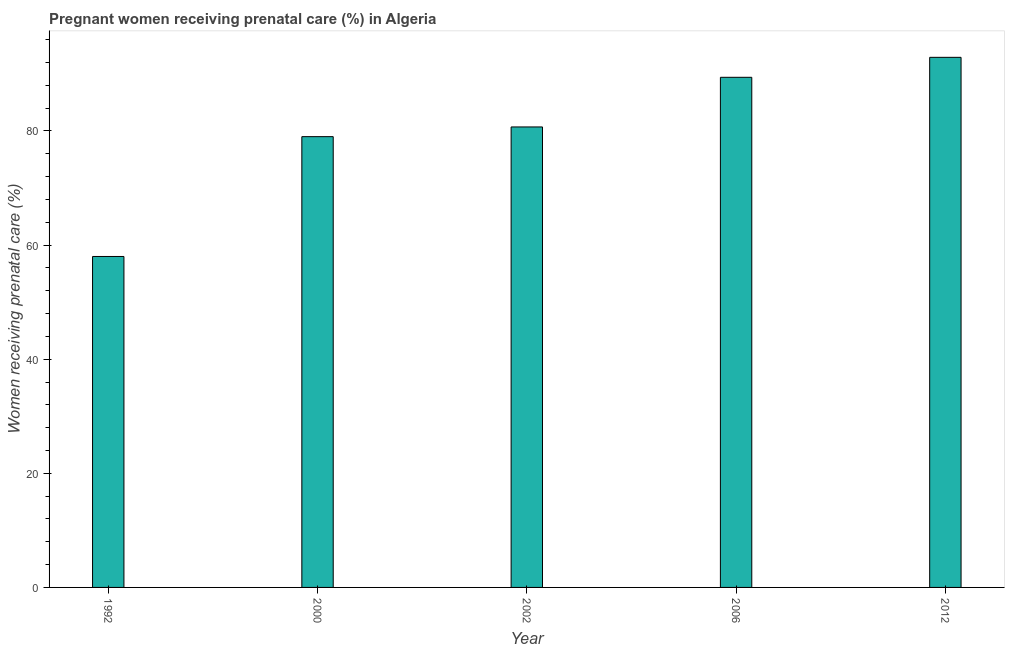Does the graph contain any zero values?
Your answer should be very brief. No. What is the title of the graph?
Give a very brief answer. Pregnant women receiving prenatal care (%) in Algeria. What is the label or title of the X-axis?
Provide a short and direct response. Year. What is the label or title of the Y-axis?
Offer a terse response. Women receiving prenatal care (%). What is the percentage of pregnant women receiving prenatal care in 2000?
Provide a short and direct response. 79. Across all years, what is the maximum percentage of pregnant women receiving prenatal care?
Offer a terse response. 92.9. In which year was the percentage of pregnant women receiving prenatal care maximum?
Provide a succinct answer. 2012. What is the difference between the percentage of pregnant women receiving prenatal care in 2000 and 2002?
Your response must be concise. -1.7. What is the median percentage of pregnant women receiving prenatal care?
Your answer should be very brief. 80.7. Do a majority of the years between 2002 and 2006 (inclusive) have percentage of pregnant women receiving prenatal care greater than 76 %?
Ensure brevity in your answer.  Yes. What is the ratio of the percentage of pregnant women receiving prenatal care in 1992 to that in 2006?
Make the answer very short. 0.65. Is the percentage of pregnant women receiving prenatal care in 2002 less than that in 2006?
Provide a succinct answer. Yes. What is the difference between the highest and the second highest percentage of pregnant women receiving prenatal care?
Offer a terse response. 3.5. What is the difference between the highest and the lowest percentage of pregnant women receiving prenatal care?
Your response must be concise. 34.9. In how many years, is the percentage of pregnant women receiving prenatal care greater than the average percentage of pregnant women receiving prenatal care taken over all years?
Provide a short and direct response. 3. Are all the bars in the graph horizontal?
Your answer should be compact. No. What is the Women receiving prenatal care (%) of 1992?
Offer a very short reply. 58. What is the Women receiving prenatal care (%) in 2000?
Provide a succinct answer. 79. What is the Women receiving prenatal care (%) of 2002?
Provide a succinct answer. 80.7. What is the Women receiving prenatal care (%) of 2006?
Make the answer very short. 89.4. What is the Women receiving prenatal care (%) of 2012?
Your answer should be very brief. 92.9. What is the difference between the Women receiving prenatal care (%) in 1992 and 2002?
Your answer should be compact. -22.7. What is the difference between the Women receiving prenatal care (%) in 1992 and 2006?
Offer a terse response. -31.4. What is the difference between the Women receiving prenatal care (%) in 1992 and 2012?
Keep it short and to the point. -34.9. What is the difference between the Women receiving prenatal care (%) in 2000 and 2002?
Provide a short and direct response. -1.7. What is the difference between the Women receiving prenatal care (%) in 2000 and 2006?
Your response must be concise. -10.4. What is the difference between the Women receiving prenatal care (%) in 2000 and 2012?
Your answer should be compact. -13.9. What is the difference between the Women receiving prenatal care (%) in 2002 and 2006?
Your response must be concise. -8.7. What is the ratio of the Women receiving prenatal care (%) in 1992 to that in 2000?
Your answer should be very brief. 0.73. What is the ratio of the Women receiving prenatal care (%) in 1992 to that in 2002?
Keep it short and to the point. 0.72. What is the ratio of the Women receiving prenatal care (%) in 1992 to that in 2006?
Your answer should be compact. 0.65. What is the ratio of the Women receiving prenatal care (%) in 1992 to that in 2012?
Make the answer very short. 0.62. What is the ratio of the Women receiving prenatal care (%) in 2000 to that in 2006?
Make the answer very short. 0.88. What is the ratio of the Women receiving prenatal care (%) in 2002 to that in 2006?
Provide a short and direct response. 0.9. What is the ratio of the Women receiving prenatal care (%) in 2002 to that in 2012?
Keep it short and to the point. 0.87. What is the ratio of the Women receiving prenatal care (%) in 2006 to that in 2012?
Your answer should be very brief. 0.96. 